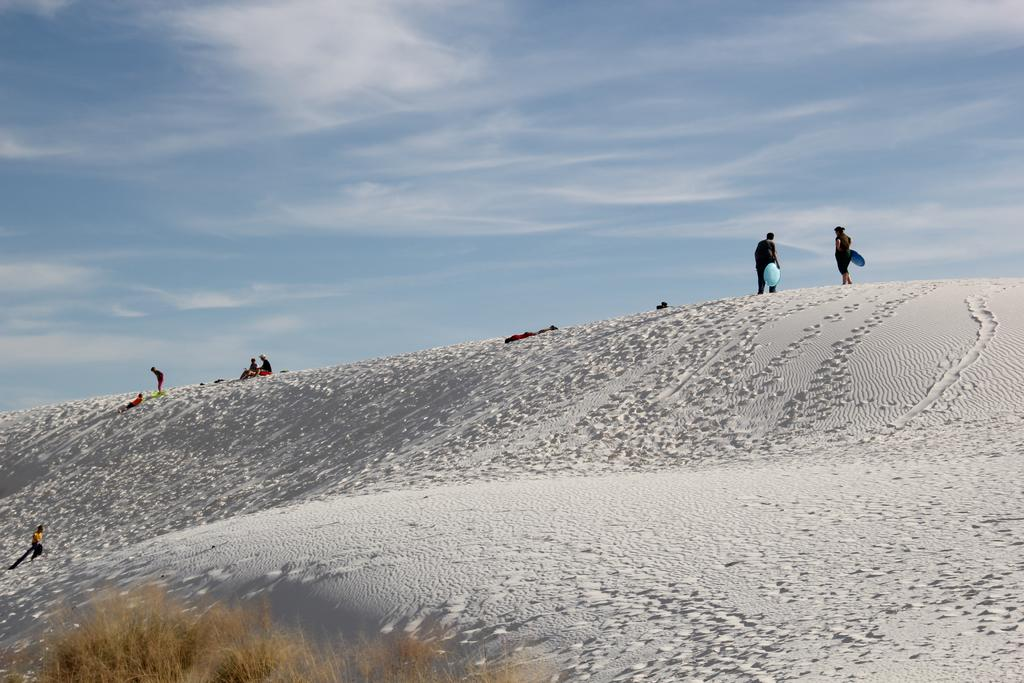How many people can be seen in the image? There are a few people in the image. What is covering the ground in the image? The ground is covered with snow. What type of vegetation is visible at the bottom of the image? There is dried grass at the bottom of the image. What can be seen in the sky in the image? The sky is visible in the image, and clouds are present. What type of egg is being used for comparison in the image? There is no egg present in the image, and therefore no comparison can be made. 